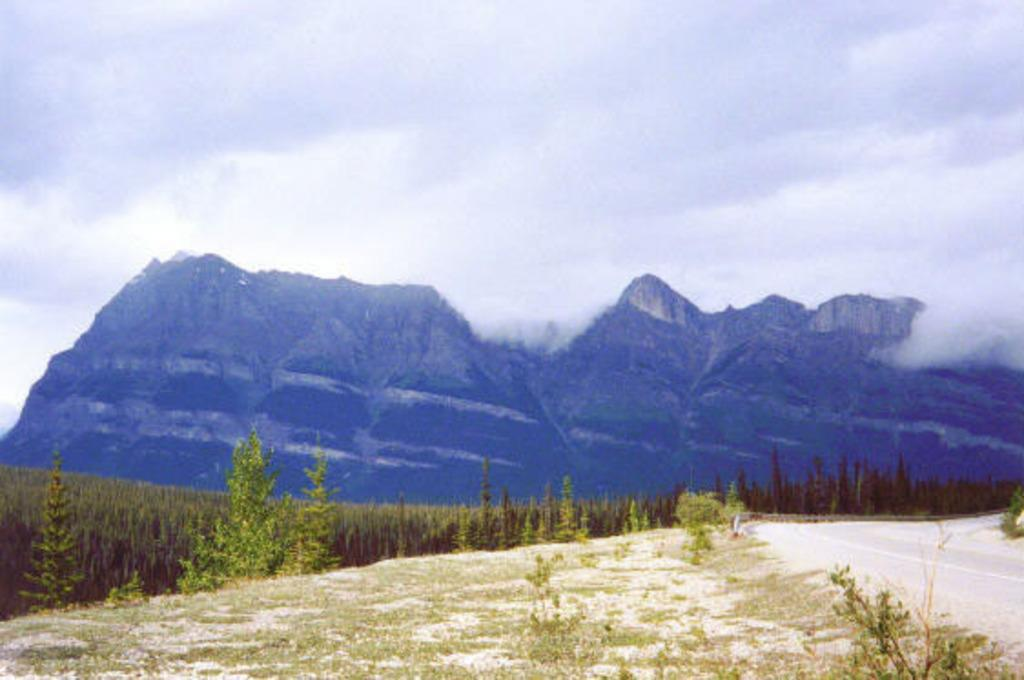What type of vegetation can be seen in the image? There are trees, plants, and grass in the image. What geographical feature is visible in the image? There are mountains in the image. What man-made structure is present in the image? There is a road in the image. What is visible in the background of the image? The sky is visible in the background of the image, with clouds present. What type of stamp can be seen on the trees in the image? There are no stamps present on the trees in the image. 